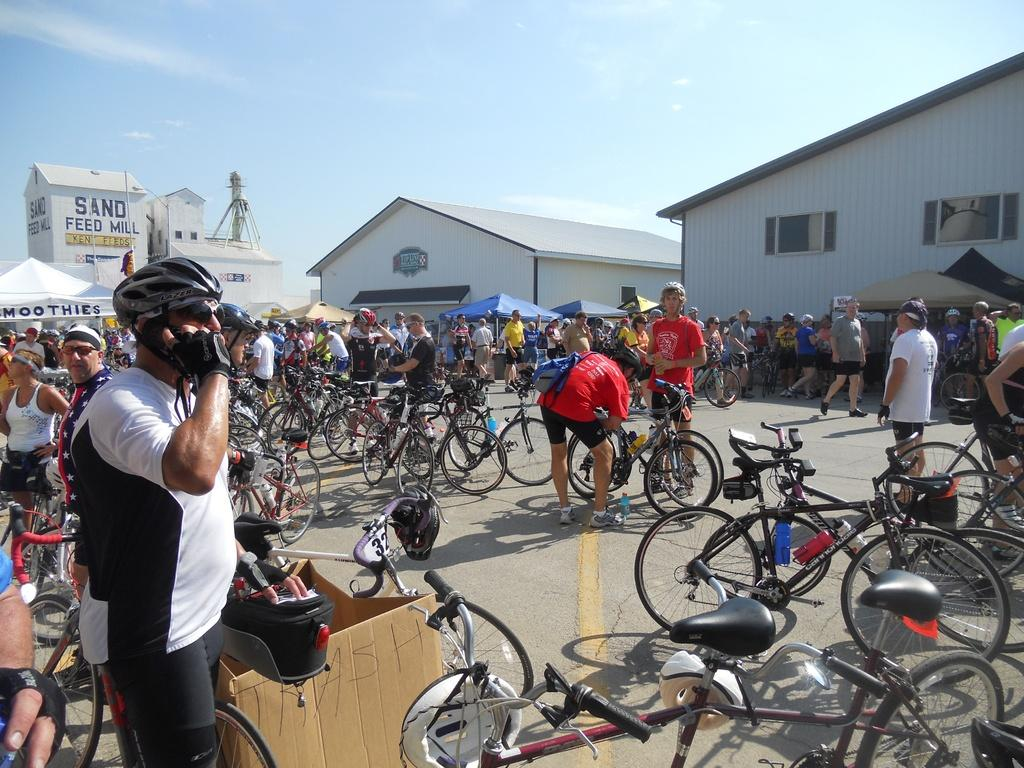What can be seen in large numbers in the image? There are many bicycles in the image. What are the people in the image doing? There are people standing on the road in the image. Can you describe an object in the image that is typically used for packaging or storage? There is a cardboard box in the image. What type of temporary shelter is visible in the image? There are tents in the image. What type of permanent structures can be seen in the image? There are houses in the image. What is visible in the background of the image? The sky is visible in the background of the image. What type of locket is hanging from the bicycle in the image? There is no locket hanging from any bicycle in the image. What type of lumber is being used to construct the houses in the image? The image does not provide information about the materials used to construct the houses. What type of iron is visible in the image? There is no iron visible in the image. 